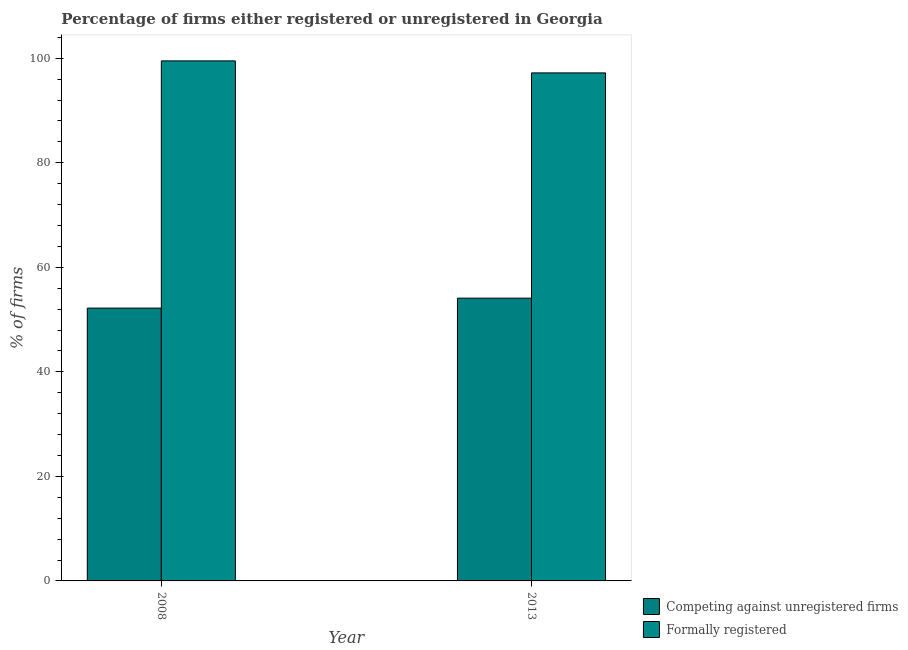How many groups of bars are there?
Your answer should be very brief. 2. Are the number of bars per tick equal to the number of legend labels?
Give a very brief answer. Yes. Are the number of bars on each tick of the X-axis equal?
Make the answer very short. Yes. How many bars are there on the 2nd tick from the right?
Your answer should be compact. 2. What is the label of the 2nd group of bars from the left?
Keep it short and to the point. 2013. What is the percentage of formally registered firms in 2013?
Your response must be concise. 97.2. Across all years, what is the maximum percentage of registered firms?
Your response must be concise. 54.1. Across all years, what is the minimum percentage of registered firms?
Provide a short and direct response. 52.2. What is the total percentage of registered firms in the graph?
Offer a terse response. 106.3. What is the difference between the percentage of registered firms in 2008 and that in 2013?
Your answer should be compact. -1.9. What is the difference between the percentage of registered firms in 2008 and the percentage of formally registered firms in 2013?
Your answer should be very brief. -1.9. What is the average percentage of registered firms per year?
Give a very brief answer. 53.15. What is the ratio of the percentage of registered firms in 2008 to that in 2013?
Provide a short and direct response. 0.96. What does the 2nd bar from the left in 2008 represents?
Keep it short and to the point. Formally registered. What does the 1st bar from the right in 2013 represents?
Your response must be concise. Formally registered. How many years are there in the graph?
Offer a very short reply. 2. Does the graph contain any zero values?
Your answer should be very brief. No. Where does the legend appear in the graph?
Offer a terse response. Bottom right. How are the legend labels stacked?
Offer a terse response. Vertical. What is the title of the graph?
Provide a succinct answer. Percentage of firms either registered or unregistered in Georgia. Does "Infant" appear as one of the legend labels in the graph?
Keep it short and to the point. No. What is the label or title of the Y-axis?
Ensure brevity in your answer.  % of firms. What is the % of firms of Competing against unregistered firms in 2008?
Ensure brevity in your answer.  52.2. What is the % of firms of Formally registered in 2008?
Ensure brevity in your answer.  99.5. What is the % of firms in Competing against unregistered firms in 2013?
Ensure brevity in your answer.  54.1. What is the % of firms of Formally registered in 2013?
Ensure brevity in your answer.  97.2. Across all years, what is the maximum % of firms of Competing against unregistered firms?
Ensure brevity in your answer.  54.1. Across all years, what is the maximum % of firms of Formally registered?
Offer a very short reply. 99.5. Across all years, what is the minimum % of firms of Competing against unregistered firms?
Your response must be concise. 52.2. Across all years, what is the minimum % of firms of Formally registered?
Provide a succinct answer. 97.2. What is the total % of firms of Competing against unregistered firms in the graph?
Your response must be concise. 106.3. What is the total % of firms of Formally registered in the graph?
Your response must be concise. 196.7. What is the difference between the % of firms in Competing against unregistered firms in 2008 and that in 2013?
Provide a succinct answer. -1.9. What is the difference between the % of firms of Competing against unregistered firms in 2008 and the % of firms of Formally registered in 2013?
Provide a succinct answer. -45. What is the average % of firms of Competing against unregistered firms per year?
Make the answer very short. 53.15. What is the average % of firms in Formally registered per year?
Make the answer very short. 98.35. In the year 2008, what is the difference between the % of firms of Competing against unregistered firms and % of firms of Formally registered?
Give a very brief answer. -47.3. In the year 2013, what is the difference between the % of firms of Competing against unregistered firms and % of firms of Formally registered?
Keep it short and to the point. -43.1. What is the ratio of the % of firms of Competing against unregistered firms in 2008 to that in 2013?
Offer a very short reply. 0.96. What is the ratio of the % of firms of Formally registered in 2008 to that in 2013?
Give a very brief answer. 1.02. What is the difference between the highest and the lowest % of firms in Competing against unregistered firms?
Offer a terse response. 1.9. 